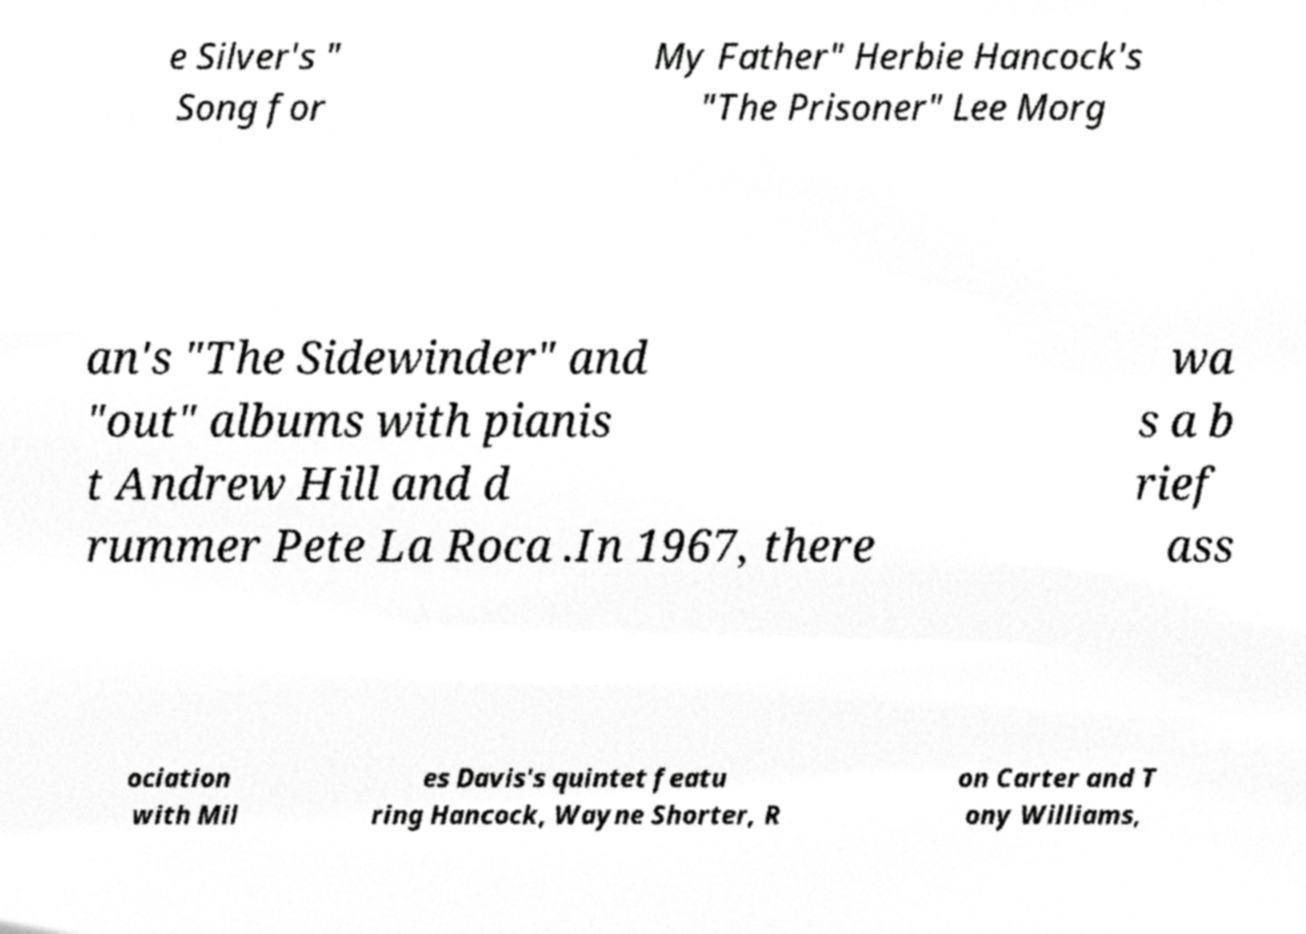Could you assist in decoding the text presented in this image and type it out clearly? e Silver's " Song for My Father" Herbie Hancock's "The Prisoner" Lee Morg an's "The Sidewinder" and "out" albums with pianis t Andrew Hill and d rummer Pete La Roca .In 1967, there wa s a b rief ass ociation with Mil es Davis's quintet featu ring Hancock, Wayne Shorter, R on Carter and T ony Williams, 